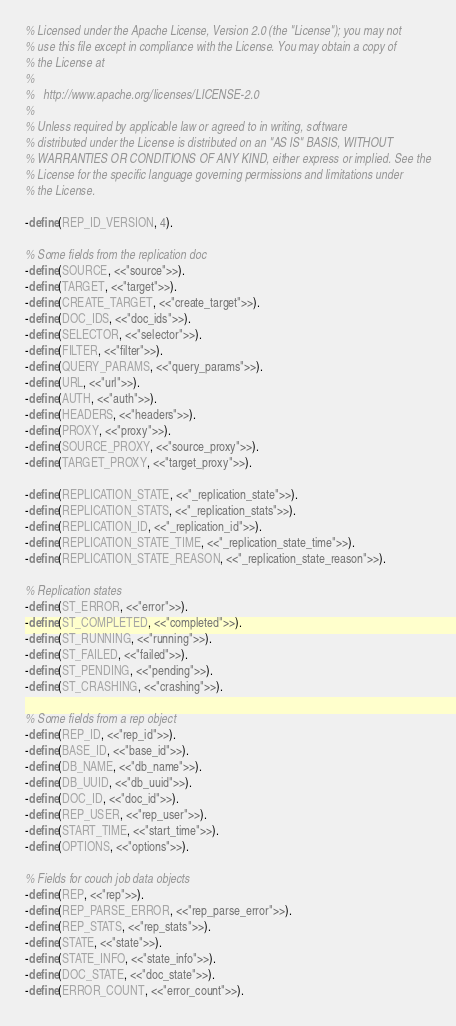<code> <loc_0><loc_0><loc_500><loc_500><_Erlang_>% Licensed under the Apache License, Version 2.0 (the "License"); you may not
% use this file except in compliance with the License. You may obtain a copy of
% the License at
%
%   http://www.apache.org/licenses/LICENSE-2.0
%
% Unless required by applicable law or agreed to in writing, software
% distributed under the License is distributed on an "AS IS" BASIS, WITHOUT
% WARRANTIES OR CONDITIONS OF ANY KIND, either express or implied. See the
% License for the specific language governing permissions and limitations under
% the License.

-define(REP_ID_VERSION, 4).

% Some fields from the replication doc
-define(SOURCE, <<"source">>).
-define(TARGET, <<"target">>).
-define(CREATE_TARGET, <<"create_target">>).
-define(DOC_IDS, <<"doc_ids">>).
-define(SELECTOR, <<"selector">>).
-define(FILTER, <<"filter">>).
-define(QUERY_PARAMS, <<"query_params">>).
-define(URL, <<"url">>).
-define(AUTH, <<"auth">>).
-define(HEADERS, <<"headers">>).
-define(PROXY, <<"proxy">>).
-define(SOURCE_PROXY, <<"source_proxy">>).
-define(TARGET_PROXY, <<"target_proxy">>).

-define(REPLICATION_STATE, <<"_replication_state">>).
-define(REPLICATION_STATS, <<"_replication_stats">>).
-define(REPLICATION_ID, <<"_replication_id">>).
-define(REPLICATION_STATE_TIME, <<"_replication_state_time">>).
-define(REPLICATION_STATE_REASON, <<"_replication_state_reason">>).

% Replication states
-define(ST_ERROR, <<"error">>).
-define(ST_COMPLETED, <<"completed">>).
-define(ST_RUNNING, <<"running">>).
-define(ST_FAILED, <<"failed">>).
-define(ST_PENDING, <<"pending">>).
-define(ST_CRASHING, <<"crashing">>).

% Some fields from a rep object
-define(REP_ID, <<"rep_id">>).
-define(BASE_ID, <<"base_id">>).
-define(DB_NAME, <<"db_name">>).
-define(DB_UUID, <<"db_uuid">>).
-define(DOC_ID, <<"doc_id">>).
-define(REP_USER, <<"rep_user">>).
-define(START_TIME, <<"start_time">>).
-define(OPTIONS, <<"options">>).

% Fields for couch job data objects
-define(REP, <<"rep">>).
-define(REP_PARSE_ERROR, <<"rep_parse_error">>).
-define(REP_STATS, <<"rep_stats">>).
-define(STATE, <<"state">>).
-define(STATE_INFO, <<"state_info">>).
-define(DOC_STATE, <<"doc_state">>).
-define(ERROR_COUNT, <<"error_count">>).</code> 